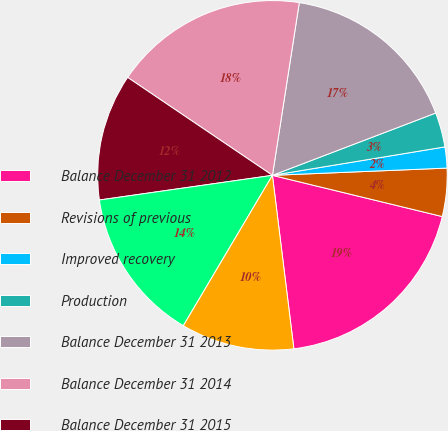Convert chart to OTSL. <chart><loc_0><loc_0><loc_500><loc_500><pie_chart><fcel>Balance December 31 2012<fcel>Revisions of previous<fcel>Improved recovery<fcel>Production<fcel>Balance December 31 2013<fcel>Balance December 31 2014<fcel>Balance December 31 2015<fcel>December 31 2012<fcel>December 31 2013<nl><fcel>19.25%<fcel>4.45%<fcel>1.94%<fcel>3.2%<fcel>16.74%<fcel>17.99%<fcel>11.72%<fcel>14.23%<fcel>10.47%<nl></chart> 